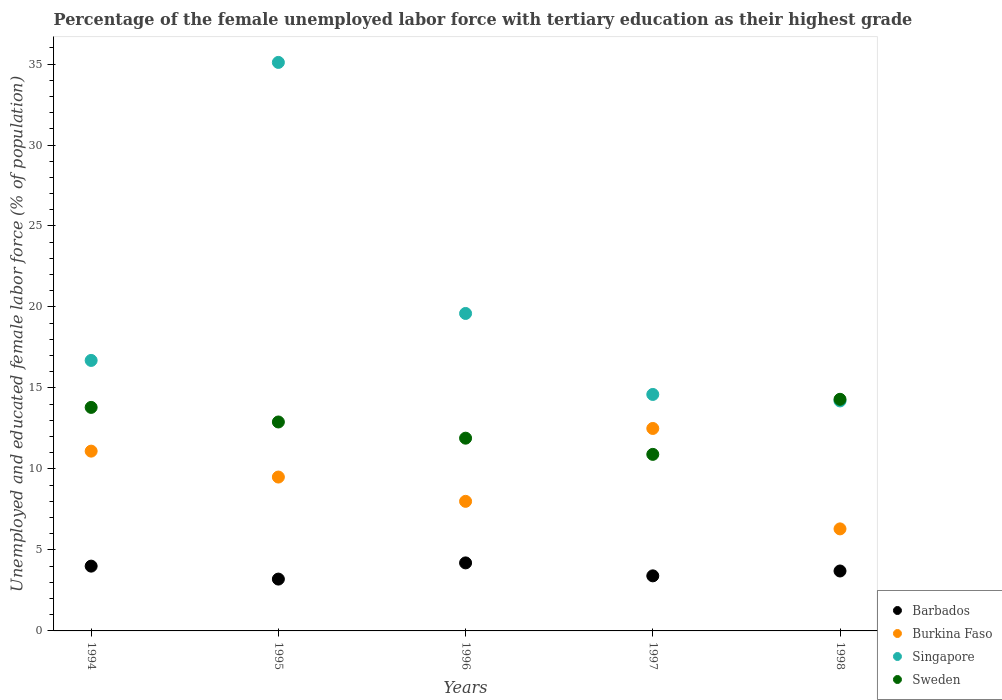How many different coloured dotlines are there?
Your response must be concise. 4. Is the number of dotlines equal to the number of legend labels?
Offer a terse response. Yes. What is the percentage of the unemployed female labor force with tertiary education in Singapore in 1997?
Offer a very short reply. 14.6. Across all years, what is the maximum percentage of the unemployed female labor force with tertiary education in Sweden?
Offer a terse response. 14.3. Across all years, what is the minimum percentage of the unemployed female labor force with tertiary education in Sweden?
Offer a very short reply. 10.9. In which year was the percentage of the unemployed female labor force with tertiary education in Barbados minimum?
Provide a short and direct response. 1995. What is the total percentage of the unemployed female labor force with tertiary education in Burkina Faso in the graph?
Ensure brevity in your answer.  47.4. What is the difference between the percentage of the unemployed female labor force with tertiary education in Singapore in 1995 and the percentage of the unemployed female labor force with tertiary education in Burkina Faso in 1996?
Provide a succinct answer. 27.1. What is the average percentage of the unemployed female labor force with tertiary education in Barbados per year?
Make the answer very short. 3.7. In the year 1994, what is the difference between the percentage of the unemployed female labor force with tertiary education in Sweden and percentage of the unemployed female labor force with tertiary education in Burkina Faso?
Your answer should be very brief. 2.7. What is the ratio of the percentage of the unemployed female labor force with tertiary education in Sweden in 1994 to that in 1998?
Your answer should be compact. 0.97. Is the percentage of the unemployed female labor force with tertiary education in Singapore in 1996 less than that in 1997?
Ensure brevity in your answer.  No. Is the difference between the percentage of the unemployed female labor force with tertiary education in Sweden in 1994 and 1995 greater than the difference between the percentage of the unemployed female labor force with tertiary education in Burkina Faso in 1994 and 1995?
Your answer should be very brief. No. What is the difference between the highest and the second highest percentage of the unemployed female labor force with tertiary education in Burkina Faso?
Make the answer very short. 1.4. What is the difference between the highest and the lowest percentage of the unemployed female labor force with tertiary education in Burkina Faso?
Offer a very short reply. 6.2. Does the percentage of the unemployed female labor force with tertiary education in Barbados monotonically increase over the years?
Ensure brevity in your answer.  No. Is the percentage of the unemployed female labor force with tertiary education in Barbados strictly less than the percentage of the unemployed female labor force with tertiary education in Singapore over the years?
Keep it short and to the point. Yes. How many dotlines are there?
Your response must be concise. 4. Are the values on the major ticks of Y-axis written in scientific E-notation?
Your answer should be compact. No. Does the graph contain grids?
Make the answer very short. No. How many legend labels are there?
Make the answer very short. 4. What is the title of the graph?
Keep it short and to the point. Percentage of the female unemployed labor force with tertiary education as their highest grade. Does "Algeria" appear as one of the legend labels in the graph?
Make the answer very short. No. What is the label or title of the Y-axis?
Make the answer very short. Unemployed and educated female labor force (% of population). What is the Unemployed and educated female labor force (% of population) of Burkina Faso in 1994?
Give a very brief answer. 11.1. What is the Unemployed and educated female labor force (% of population) of Singapore in 1994?
Offer a very short reply. 16.7. What is the Unemployed and educated female labor force (% of population) in Sweden in 1994?
Provide a succinct answer. 13.8. What is the Unemployed and educated female labor force (% of population) in Barbados in 1995?
Keep it short and to the point. 3.2. What is the Unemployed and educated female labor force (% of population) of Singapore in 1995?
Offer a very short reply. 35.1. What is the Unemployed and educated female labor force (% of population) of Sweden in 1995?
Provide a succinct answer. 12.9. What is the Unemployed and educated female labor force (% of population) of Barbados in 1996?
Offer a very short reply. 4.2. What is the Unemployed and educated female labor force (% of population) in Singapore in 1996?
Your response must be concise. 19.6. What is the Unemployed and educated female labor force (% of population) in Sweden in 1996?
Provide a succinct answer. 11.9. What is the Unemployed and educated female labor force (% of population) of Barbados in 1997?
Ensure brevity in your answer.  3.4. What is the Unemployed and educated female labor force (% of population) of Singapore in 1997?
Offer a terse response. 14.6. What is the Unemployed and educated female labor force (% of population) of Sweden in 1997?
Offer a terse response. 10.9. What is the Unemployed and educated female labor force (% of population) in Barbados in 1998?
Keep it short and to the point. 3.7. What is the Unemployed and educated female labor force (% of population) of Burkina Faso in 1998?
Your answer should be compact. 6.3. What is the Unemployed and educated female labor force (% of population) of Singapore in 1998?
Ensure brevity in your answer.  14.2. What is the Unemployed and educated female labor force (% of population) in Sweden in 1998?
Provide a succinct answer. 14.3. Across all years, what is the maximum Unemployed and educated female labor force (% of population) in Barbados?
Offer a very short reply. 4.2. Across all years, what is the maximum Unemployed and educated female labor force (% of population) in Singapore?
Your answer should be very brief. 35.1. Across all years, what is the maximum Unemployed and educated female labor force (% of population) of Sweden?
Provide a short and direct response. 14.3. Across all years, what is the minimum Unemployed and educated female labor force (% of population) in Barbados?
Offer a very short reply. 3.2. Across all years, what is the minimum Unemployed and educated female labor force (% of population) of Burkina Faso?
Your response must be concise. 6.3. Across all years, what is the minimum Unemployed and educated female labor force (% of population) of Singapore?
Give a very brief answer. 14.2. Across all years, what is the minimum Unemployed and educated female labor force (% of population) of Sweden?
Provide a succinct answer. 10.9. What is the total Unemployed and educated female labor force (% of population) of Barbados in the graph?
Give a very brief answer. 18.5. What is the total Unemployed and educated female labor force (% of population) in Burkina Faso in the graph?
Your response must be concise. 47.4. What is the total Unemployed and educated female labor force (% of population) of Singapore in the graph?
Provide a succinct answer. 100.2. What is the total Unemployed and educated female labor force (% of population) of Sweden in the graph?
Your answer should be compact. 63.8. What is the difference between the Unemployed and educated female labor force (% of population) of Singapore in 1994 and that in 1995?
Your response must be concise. -18.4. What is the difference between the Unemployed and educated female labor force (% of population) of Barbados in 1994 and that in 1996?
Ensure brevity in your answer.  -0.2. What is the difference between the Unemployed and educated female labor force (% of population) of Singapore in 1994 and that in 1996?
Offer a terse response. -2.9. What is the difference between the Unemployed and educated female labor force (% of population) in Sweden in 1994 and that in 1996?
Your response must be concise. 1.9. What is the difference between the Unemployed and educated female labor force (% of population) of Barbados in 1994 and that in 1997?
Your response must be concise. 0.6. What is the difference between the Unemployed and educated female labor force (% of population) in Burkina Faso in 1994 and that in 1997?
Offer a very short reply. -1.4. What is the difference between the Unemployed and educated female labor force (% of population) in Barbados in 1994 and that in 1998?
Your answer should be very brief. 0.3. What is the difference between the Unemployed and educated female labor force (% of population) in Burkina Faso in 1994 and that in 1998?
Your response must be concise. 4.8. What is the difference between the Unemployed and educated female labor force (% of population) in Barbados in 1995 and that in 1996?
Your response must be concise. -1. What is the difference between the Unemployed and educated female labor force (% of population) in Burkina Faso in 1995 and that in 1996?
Ensure brevity in your answer.  1.5. What is the difference between the Unemployed and educated female labor force (% of population) in Burkina Faso in 1995 and that in 1997?
Provide a short and direct response. -3. What is the difference between the Unemployed and educated female labor force (% of population) of Barbados in 1995 and that in 1998?
Give a very brief answer. -0.5. What is the difference between the Unemployed and educated female labor force (% of population) of Singapore in 1995 and that in 1998?
Make the answer very short. 20.9. What is the difference between the Unemployed and educated female labor force (% of population) in Sweden in 1995 and that in 1998?
Give a very brief answer. -1.4. What is the difference between the Unemployed and educated female labor force (% of population) in Burkina Faso in 1996 and that in 1997?
Offer a terse response. -4.5. What is the difference between the Unemployed and educated female labor force (% of population) of Singapore in 1996 and that in 1997?
Your answer should be very brief. 5. What is the difference between the Unemployed and educated female labor force (% of population) in Barbados in 1996 and that in 1998?
Give a very brief answer. 0.5. What is the difference between the Unemployed and educated female labor force (% of population) in Burkina Faso in 1996 and that in 1998?
Your answer should be very brief. 1.7. What is the difference between the Unemployed and educated female labor force (% of population) of Barbados in 1997 and that in 1998?
Offer a very short reply. -0.3. What is the difference between the Unemployed and educated female labor force (% of population) of Burkina Faso in 1997 and that in 1998?
Your answer should be very brief. 6.2. What is the difference between the Unemployed and educated female labor force (% of population) in Sweden in 1997 and that in 1998?
Provide a succinct answer. -3.4. What is the difference between the Unemployed and educated female labor force (% of population) in Barbados in 1994 and the Unemployed and educated female labor force (% of population) in Burkina Faso in 1995?
Ensure brevity in your answer.  -5.5. What is the difference between the Unemployed and educated female labor force (% of population) in Barbados in 1994 and the Unemployed and educated female labor force (% of population) in Singapore in 1995?
Your response must be concise. -31.1. What is the difference between the Unemployed and educated female labor force (% of population) in Barbados in 1994 and the Unemployed and educated female labor force (% of population) in Sweden in 1995?
Ensure brevity in your answer.  -8.9. What is the difference between the Unemployed and educated female labor force (% of population) of Burkina Faso in 1994 and the Unemployed and educated female labor force (% of population) of Singapore in 1995?
Provide a short and direct response. -24. What is the difference between the Unemployed and educated female labor force (% of population) of Burkina Faso in 1994 and the Unemployed and educated female labor force (% of population) of Sweden in 1995?
Provide a short and direct response. -1.8. What is the difference between the Unemployed and educated female labor force (% of population) in Barbados in 1994 and the Unemployed and educated female labor force (% of population) in Burkina Faso in 1996?
Your answer should be compact. -4. What is the difference between the Unemployed and educated female labor force (% of population) of Barbados in 1994 and the Unemployed and educated female labor force (% of population) of Singapore in 1996?
Provide a succinct answer. -15.6. What is the difference between the Unemployed and educated female labor force (% of population) in Barbados in 1994 and the Unemployed and educated female labor force (% of population) in Sweden in 1996?
Make the answer very short. -7.9. What is the difference between the Unemployed and educated female labor force (% of population) of Singapore in 1994 and the Unemployed and educated female labor force (% of population) of Sweden in 1996?
Your answer should be very brief. 4.8. What is the difference between the Unemployed and educated female labor force (% of population) in Barbados in 1994 and the Unemployed and educated female labor force (% of population) in Burkina Faso in 1997?
Your response must be concise. -8.5. What is the difference between the Unemployed and educated female labor force (% of population) of Burkina Faso in 1994 and the Unemployed and educated female labor force (% of population) of Sweden in 1997?
Offer a very short reply. 0.2. What is the difference between the Unemployed and educated female labor force (% of population) in Singapore in 1994 and the Unemployed and educated female labor force (% of population) in Sweden in 1997?
Offer a very short reply. 5.8. What is the difference between the Unemployed and educated female labor force (% of population) in Barbados in 1994 and the Unemployed and educated female labor force (% of population) in Burkina Faso in 1998?
Ensure brevity in your answer.  -2.3. What is the difference between the Unemployed and educated female labor force (% of population) in Barbados in 1994 and the Unemployed and educated female labor force (% of population) in Singapore in 1998?
Provide a succinct answer. -10.2. What is the difference between the Unemployed and educated female labor force (% of population) in Burkina Faso in 1994 and the Unemployed and educated female labor force (% of population) in Singapore in 1998?
Provide a succinct answer. -3.1. What is the difference between the Unemployed and educated female labor force (% of population) in Burkina Faso in 1994 and the Unemployed and educated female labor force (% of population) in Sweden in 1998?
Your response must be concise. -3.2. What is the difference between the Unemployed and educated female labor force (% of population) in Singapore in 1994 and the Unemployed and educated female labor force (% of population) in Sweden in 1998?
Give a very brief answer. 2.4. What is the difference between the Unemployed and educated female labor force (% of population) in Barbados in 1995 and the Unemployed and educated female labor force (% of population) in Burkina Faso in 1996?
Your response must be concise. -4.8. What is the difference between the Unemployed and educated female labor force (% of population) of Barbados in 1995 and the Unemployed and educated female labor force (% of population) of Singapore in 1996?
Your response must be concise. -16.4. What is the difference between the Unemployed and educated female labor force (% of population) of Barbados in 1995 and the Unemployed and educated female labor force (% of population) of Sweden in 1996?
Ensure brevity in your answer.  -8.7. What is the difference between the Unemployed and educated female labor force (% of population) in Burkina Faso in 1995 and the Unemployed and educated female labor force (% of population) in Singapore in 1996?
Your response must be concise. -10.1. What is the difference between the Unemployed and educated female labor force (% of population) in Burkina Faso in 1995 and the Unemployed and educated female labor force (% of population) in Sweden in 1996?
Provide a short and direct response. -2.4. What is the difference between the Unemployed and educated female labor force (% of population) in Singapore in 1995 and the Unemployed and educated female labor force (% of population) in Sweden in 1996?
Ensure brevity in your answer.  23.2. What is the difference between the Unemployed and educated female labor force (% of population) of Barbados in 1995 and the Unemployed and educated female labor force (% of population) of Burkina Faso in 1997?
Provide a short and direct response. -9.3. What is the difference between the Unemployed and educated female labor force (% of population) in Barbados in 1995 and the Unemployed and educated female labor force (% of population) in Sweden in 1997?
Give a very brief answer. -7.7. What is the difference between the Unemployed and educated female labor force (% of population) in Singapore in 1995 and the Unemployed and educated female labor force (% of population) in Sweden in 1997?
Your response must be concise. 24.2. What is the difference between the Unemployed and educated female labor force (% of population) in Barbados in 1995 and the Unemployed and educated female labor force (% of population) in Burkina Faso in 1998?
Make the answer very short. -3.1. What is the difference between the Unemployed and educated female labor force (% of population) in Barbados in 1995 and the Unemployed and educated female labor force (% of population) in Singapore in 1998?
Offer a very short reply. -11. What is the difference between the Unemployed and educated female labor force (% of population) in Singapore in 1995 and the Unemployed and educated female labor force (% of population) in Sweden in 1998?
Provide a succinct answer. 20.8. What is the difference between the Unemployed and educated female labor force (% of population) in Barbados in 1996 and the Unemployed and educated female labor force (% of population) in Burkina Faso in 1997?
Your answer should be very brief. -8.3. What is the difference between the Unemployed and educated female labor force (% of population) of Barbados in 1996 and the Unemployed and educated female labor force (% of population) of Sweden in 1997?
Keep it short and to the point. -6.7. What is the difference between the Unemployed and educated female labor force (% of population) in Singapore in 1996 and the Unemployed and educated female labor force (% of population) in Sweden in 1997?
Offer a terse response. 8.7. What is the difference between the Unemployed and educated female labor force (% of population) of Barbados in 1996 and the Unemployed and educated female labor force (% of population) of Singapore in 1998?
Make the answer very short. -10. What is the difference between the Unemployed and educated female labor force (% of population) of Barbados in 1996 and the Unemployed and educated female labor force (% of population) of Sweden in 1998?
Make the answer very short. -10.1. What is the difference between the Unemployed and educated female labor force (% of population) of Burkina Faso in 1996 and the Unemployed and educated female labor force (% of population) of Singapore in 1998?
Offer a very short reply. -6.2. What is the difference between the Unemployed and educated female labor force (% of population) of Burkina Faso in 1996 and the Unemployed and educated female labor force (% of population) of Sweden in 1998?
Your answer should be very brief. -6.3. What is the difference between the Unemployed and educated female labor force (% of population) of Singapore in 1996 and the Unemployed and educated female labor force (% of population) of Sweden in 1998?
Ensure brevity in your answer.  5.3. What is the difference between the Unemployed and educated female labor force (% of population) in Barbados in 1997 and the Unemployed and educated female labor force (% of population) in Singapore in 1998?
Provide a succinct answer. -10.8. What is the difference between the Unemployed and educated female labor force (% of population) of Burkina Faso in 1997 and the Unemployed and educated female labor force (% of population) of Singapore in 1998?
Provide a short and direct response. -1.7. What is the difference between the Unemployed and educated female labor force (% of population) of Burkina Faso in 1997 and the Unemployed and educated female labor force (% of population) of Sweden in 1998?
Your answer should be very brief. -1.8. What is the average Unemployed and educated female labor force (% of population) of Barbados per year?
Give a very brief answer. 3.7. What is the average Unemployed and educated female labor force (% of population) in Burkina Faso per year?
Keep it short and to the point. 9.48. What is the average Unemployed and educated female labor force (% of population) of Singapore per year?
Provide a succinct answer. 20.04. What is the average Unemployed and educated female labor force (% of population) in Sweden per year?
Provide a short and direct response. 12.76. In the year 1994, what is the difference between the Unemployed and educated female labor force (% of population) of Barbados and Unemployed and educated female labor force (% of population) of Burkina Faso?
Make the answer very short. -7.1. In the year 1994, what is the difference between the Unemployed and educated female labor force (% of population) in Barbados and Unemployed and educated female labor force (% of population) in Singapore?
Offer a very short reply. -12.7. In the year 1994, what is the difference between the Unemployed and educated female labor force (% of population) of Barbados and Unemployed and educated female labor force (% of population) of Sweden?
Your answer should be very brief. -9.8. In the year 1994, what is the difference between the Unemployed and educated female labor force (% of population) of Burkina Faso and Unemployed and educated female labor force (% of population) of Sweden?
Your answer should be very brief. -2.7. In the year 1994, what is the difference between the Unemployed and educated female labor force (% of population) in Singapore and Unemployed and educated female labor force (% of population) in Sweden?
Your answer should be very brief. 2.9. In the year 1995, what is the difference between the Unemployed and educated female labor force (% of population) of Barbados and Unemployed and educated female labor force (% of population) of Burkina Faso?
Give a very brief answer. -6.3. In the year 1995, what is the difference between the Unemployed and educated female labor force (% of population) of Barbados and Unemployed and educated female labor force (% of population) of Singapore?
Offer a very short reply. -31.9. In the year 1995, what is the difference between the Unemployed and educated female labor force (% of population) in Burkina Faso and Unemployed and educated female labor force (% of population) in Singapore?
Your answer should be compact. -25.6. In the year 1995, what is the difference between the Unemployed and educated female labor force (% of population) of Burkina Faso and Unemployed and educated female labor force (% of population) of Sweden?
Make the answer very short. -3.4. In the year 1996, what is the difference between the Unemployed and educated female labor force (% of population) of Barbados and Unemployed and educated female labor force (% of population) of Singapore?
Provide a short and direct response. -15.4. In the year 1996, what is the difference between the Unemployed and educated female labor force (% of population) of Barbados and Unemployed and educated female labor force (% of population) of Sweden?
Ensure brevity in your answer.  -7.7. In the year 1996, what is the difference between the Unemployed and educated female labor force (% of population) in Burkina Faso and Unemployed and educated female labor force (% of population) in Singapore?
Your answer should be very brief. -11.6. In the year 1996, what is the difference between the Unemployed and educated female labor force (% of population) of Singapore and Unemployed and educated female labor force (% of population) of Sweden?
Your answer should be compact. 7.7. In the year 1997, what is the difference between the Unemployed and educated female labor force (% of population) of Barbados and Unemployed and educated female labor force (% of population) of Sweden?
Offer a very short reply. -7.5. In the year 1997, what is the difference between the Unemployed and educated female labor force (% of population) of Burkina Faso and Unemployed and educated female labor force (% of population) of Singapore?
Keep it short and to the point. -2.1. In the year 1997, what is the difference between the Unemployed and educated female labor force (% of population) of Burkina Faso and Unemployed and educated female labor force (% of population) of Sweden?
Give a very brief answer. 1.6. In the year 1997, what is the difference between the Unemployed and educated female labor force (% of population) in Singapore and Unemployed and educated female labor force (% of population) in Sweden?
Offer a terse response. 3.7. In the year 1998, what is the difference between the Unemployed and educated female labor force (% of population) in Barbados and Unemployed and educated female labor force (% of population) in Burkina Faso?
Offer a terse response. -2.6. In the year 1998, what is the difference between the Unemployed and educated female labor force (% of population) in Barbados and Unemployed and educated female labor force (% of population) in Singapore?
Give a very brief answer. -10.5. In the year 1998, what is the difference between the Unemployed and educated female labor force (% of population) of Barbados and Unemployed and educated female labor force (% of population) of Sweden?
Your answer should be compact. -10.6. In the year 1998, what is the difference between the Unemployed and educated female labor force (% of population) of Burkina Faso and Unemployed and educated female labor force (% of population) of Singapore?
Ensure brevity in your answer.  -7.9. What is the ratio of the Unemployed and educated female labor force (% of population) in Barbados in 1994 to that in 1995?
Make the answer very short. 1.25. What is the ratio of the Unemployed and educated female labor force (% of population) in Burkina Faso in 1994 to that in 1995?
Make the answer very short. 1.17. What is the ratio of the Unemployed and educated female labor force (% of population) of Singapore in 1994 to that in 1995?
Ensure brevity in your answer.  0.48. What is the ratio of the Unemployed and educated female labor force (% of population) of Sweden in 1994 to that in 1995?
Ensure brevity in your answer.  1.07. What is the ratio of the Unemployed and educated female labor force (% of population) in Burkina Faso in 1994 to that in 1996?
Provide a short and direct response. 1.39. What is the ratio of the Unemployed and educated female labor force (% of population) of Singapore in 1994 to that in 1996?
Provide a succinct answer. 0.85. What is the ratio of the Unemployed and educated female labor force (% of population) of Sweden in 1994 to that in 1996?
Provide a short and direct response. 1.16. What is the ratio of the Unemployed and educated female labor force (% of population) of Barbados in 1994 to that in 1997?
Keep it short and to the point. 1.18. What is the ratio of the Unemployed and educated female labor force (% of population) of Burkina Faso in 1994 to that in 1997?
Provide a succinct answer. 0.89. What is the ratio of the Unemployed and educated female labor force (% of population) in Singapore in 1994 to that in 1997?
Your response must be concise. 1.14. What is the ratio of the Unemployed and educated female labor force (% of population) in Sweden in 1994 to that in 1997?
Keep it short and to the point. 1.27. What is the ratio of the Unemployed and educated female labor force (% of population) of Barbados in 1994 to that in 1998?
Keep it short and to the point. 1.08. What is the ratio of the Unemployed and educated female labor force (% of population) of Burkina Faso in 1994 to that in 1998?
Your answer should be very brief. 1.76. What is the ratio of the Unemployed and educated female labor force (% of population) in Singapore in 1994 to that in 1998?
Your answer should be very brief. 1.18. What is the ratio of the Unemployed and educated female labor force (% of population) of Sweden in 1994 to that in 1998?
Your response must be concise. 0.96. What is the ratio of the Unemployed and educated female labor force (% of population) in Barbados in 1995 to that in 1996?
Make the answer very short. 0.76. What is the ratio of the Unemployed and educated female labor force (% of population) of Burkina Faso in 1995 to that in 1996?
Your answer should be compact. 1.19. What is the ratio of the Unemployed and educated female labor force (% of population) in Singapore in 1995 to that in 1996?
Offer a terse response. 1.79. What is the ratio of the Unemployed and educated female labor force (% of population) of Sweden in 1995 to that in 1996?
Your answer should be compact. 1.08. What is the ratio of the Unemployed and educated female labor force (% of population) in Barbados in 1995 to that in 1997?
Provide a succinct answer. 0.94. What is the ratio of the Unemployed and educated female labor force (% of population) in Burkina Faso in 1995 to that in 1997?
Make the answer very short. 0.76. What is the ratio of the Unemployed and educated female labor force (% of population) of Singapore in 1995 to that in 1997?
Keep it short and to the point. 2.4. What is the ratio of the Unemployed and educated female labor force (% of population) of Sweden in 1995 to that in 1997?
Provide a short and direct response. 1.18. What is the ratio of the Unemployed and educated female labor force (% of population) of Barbados in 1995 to that in 1998?
Make the answer very short. 0.86. What is the ratio of the Unemployed and educated female labor force (% of population) of Burkina Faso in 1995 to that in 1998?
Your answer should be very brief. 1.51. What is the ratio of the Unemployed and educated female labor force (% of population) of Singapore in 1995 to that in 1998?
Ensure brevity in your answer.  2.47. What is the ratio of the Unemployed and educated female labor force (% of population) in Sweden in 1995 to that in 1998?
Offer a very short reply. 0.9. What is the ratio of the Unemployed and educated female labor force (% of population) of Barbados in 1996 to that in 1997?
Provide a succinct answer. 1.24. What is the ratio of the Unemployed and educated female labor force (% of population) in Burkina Faso in 1996 to that in 1997?
Your answer should be compact. 0.64. What is the ratio of the Unemployed and educated female labor force (% of population) of Singapore in 1996 to that in 1997?
Offer a very short reply. 1.34. What is the ratio of the Unemployed and educated female labor force (% of population) in Sweden in 1996 to that in 1997?
Offer a terse response. 1.09. What is the ratio of the Unemployed and educated female labor force (% of population) of Barbados in 1996 to that in 1998?
Make the answer very short. 1.14. What is the ratio of the Unemployed and educated female labor force (% of population) in Burkina Faso in 1996 to that in 1998?
Your answer should be very brief. 1.27. What is the ratio of the Unemployed and educated female labor force (% of population) of Singapore in 1996 to that in 1998?
Your response must be concise. 1.38. What is the ratio of the Unemployed and educated female labor force (% of population) in Sweden in 1996 to that in 1998?
Ensure brevity in your answer.  0.83. What is the ratio of the Unemployed and educated female labor force (% of population) of Barbados in 1997 to that in 1998?
Offer a very short reply. 0.92. What is the ratio of the Unemployed and educated female labor force (% of population) of Burkina Faso in 1997 to that in 1998?
Ensure brevity in your answer.  1.98. What is the ratio of the Unemployed and educated female labor force (% of population) in Singapore in 1997 to that in 1998?
Make the answer very short. 1.03. What is the ratio of the Unemployed and educated female labor force (% of population) in Sweden in 1997 to that in 1998?
Offer a very short reply. 0.76. What is the difference between the highest and the second highest Unemployed and educated female labor force (% of population) in Burkina Faso?
Provide a short and direct response. 1.4. What is the difference between the highest and the second highest Unemployed and educated female labor force (% of population) of Singapore?
Make the answer very short. 15.5. What is the difference between the highest and the second highest Unemployed and educated female labor force (% of population) of Sweden?
Provide a succinct answer. 0.5. What is the difference between the highest and the lowest Unemployed and educated female labor force (% of population) in Singapore?
Your response must be concise. 20.9. 